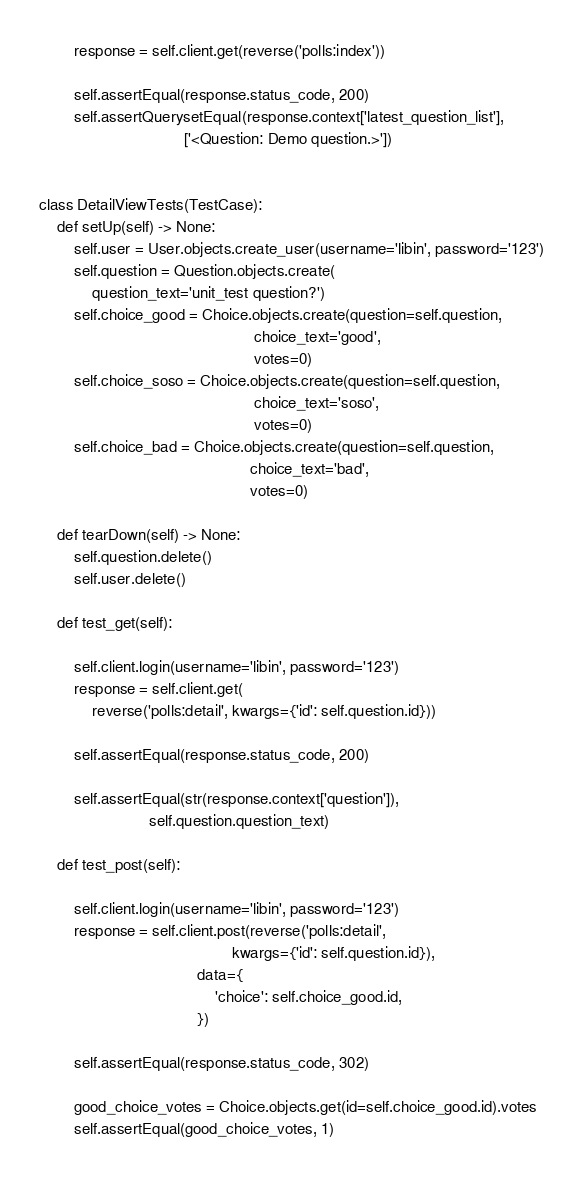Convert code to text. <code><loc_0><loc_0><loc_500><loc_500><_Python_>
        response = self.client.get(reverse('polls:index'))

        self.assertEqual(response.status_code, 200)
        self.assertQuerysetEqual(response.context['latest_question_list'],
                                 ['<Question: Demo question.>'])


class DetailViewTests(TestCase):
    def setUp(self) -> None:
        self.user = User.objects.create_user(username='libin', password='123')
        self.question = Question.objects.create(
            question_text='unit_test question?')
        self.choice_good = Choice.objects.create(question=self.question,
                                                 choice_text='good',
                                                 votes=0)
        self.choice_soso = Choice.objects.create(question=self.question,
                                                 choice_text='soso',
                                                 votes=0)
        self.choice_bad = Choice.objects.create(question=self.question,
                                                choice_text='bad',
                                                votes=0)

    def tearDown(self) -> None:
        self.question.delete()
        self.user.delete()

    def test_get(self):

        self.client.login(username='libin', password='123')
        response = self.client.get(
            reverse('polls:detail', kwargs={'id': self.question.id}))

        self.assertEqual(response.status_code, 200)

        self.assertEqual(str(response.context['question']),
                         self.question.question_text)

    def test_post(self):

        self.client.login(username='libin', password='123')
        response = self.client.post(reverse('polls:detail',
                                            kwargs={'id': self.question.id}),
                                    data={
                                        'choice': self.choice_good.id,
                                    })

        self.assertEqual(response.status_code, 302)

        good_choice_votes = Choice.objects.get(id=self.choice_good.id).votes
        self.assertEqual(good_choice_votes, 1)
</code> 